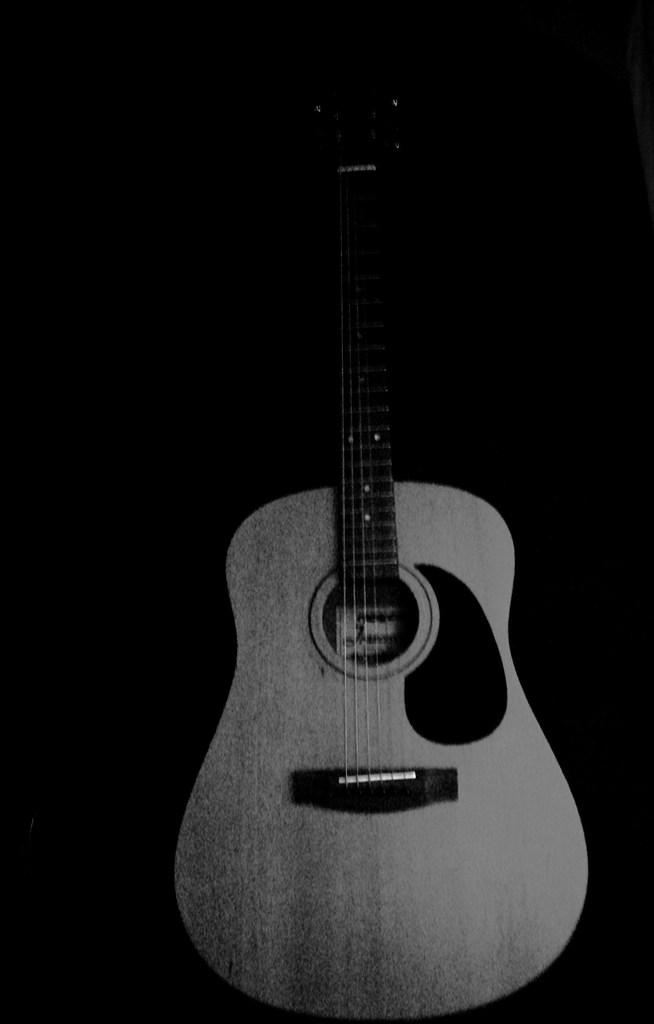What musical instrument is present in the image? There is a guitar in the image. What type of copper material is used to make the guitar in the image? The image does not provide information about the material used to make the guitar, and there is no mention of copper. 